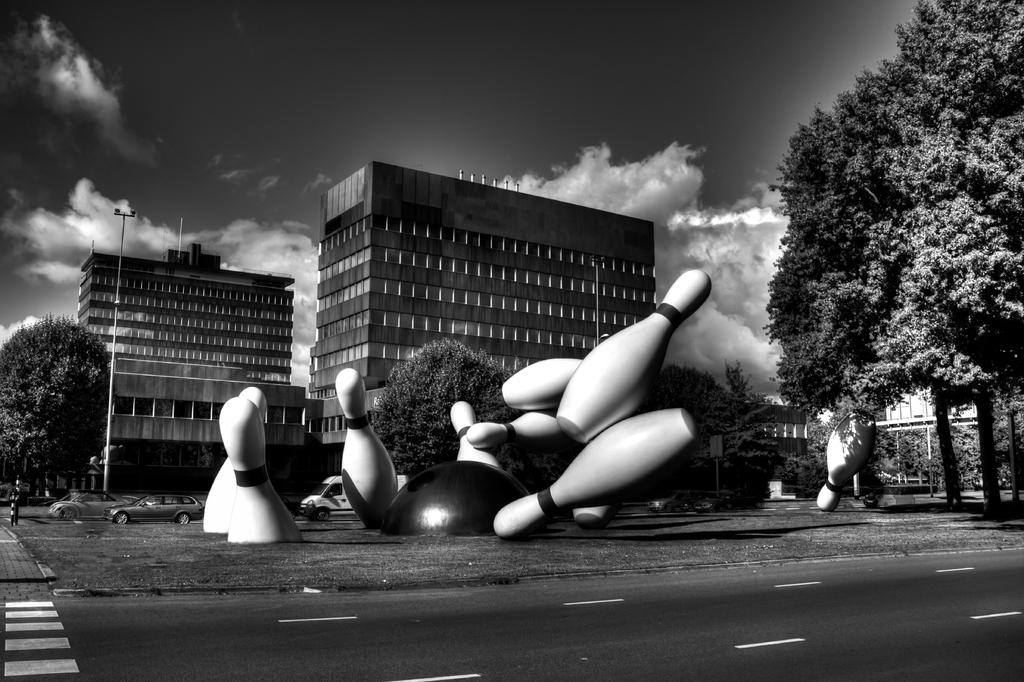What type of objects are the large items in the image? There are large bowling pins in the image. What can be seen in the foreground of the image? There is a road in the image. What type of natural elements are present in the image? There are trees in the image. What is the tall, thin object in the image? There is a pole in the image. What can be seen in the background of the image? There are buildings and the sky in the background of the image. What is the condition of the sky in the image? The sky is visible in the background of the image, and there are clouds in the sky. Where is the parcel being delivered in the image? There is no parcel present in the image. What type of oil is being extracted from the ground in the image? There is no oil extraction activity depicted in the image. 